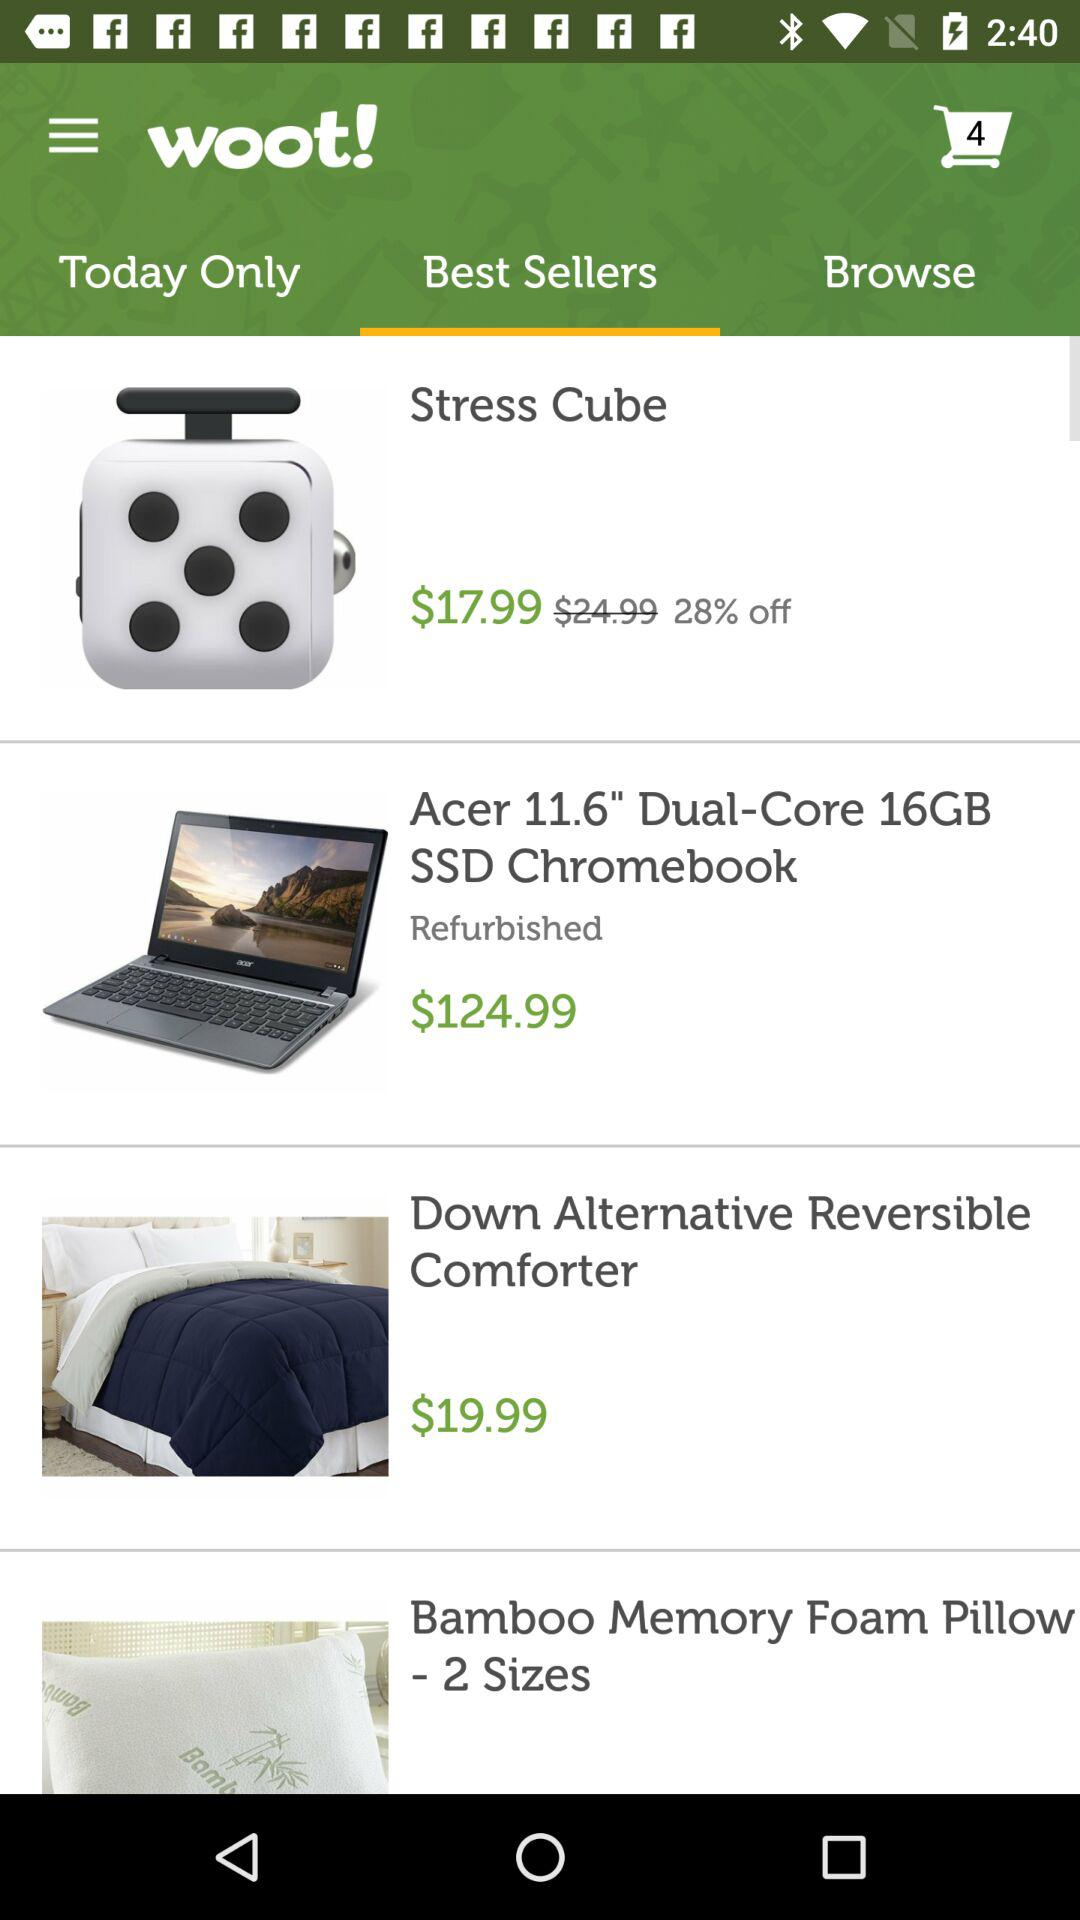What is the price of the "Stress cube"? The price is $17.99. 